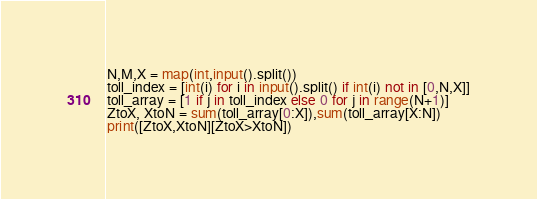Convert code to text. <code><loc_0><loc_0><loc_500><loc_500><_Python_>N,M,X = map(int,input().split())
toll_index = [int(i) for i in input().split() if int(i) not in [0,N,X]]
toll_array = [1 if j in toll_index else 0 for j in range(N+1)]
ZtoX, XtoN = sum(toll_array[0:X]),sum(toll_array[X:N])
print([ZtoX,XtoN][ZtoX>XtoN])</code> 